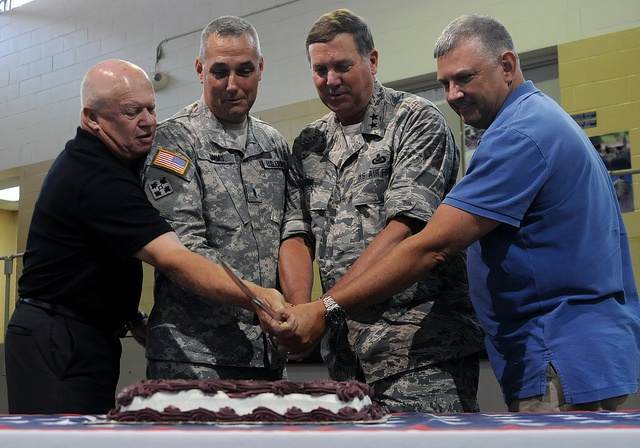Describe the objects in this image and their specific colors. I can see people in white, navy, black, blue, and brown tones, people in white, black, gray, darkgray, and brown tones, people in white, black, gray, maroon, and darkgray tones, people in white, black, gray, and darkgray tones, and cake in white, black, lightgray, and gray tones in this image. 